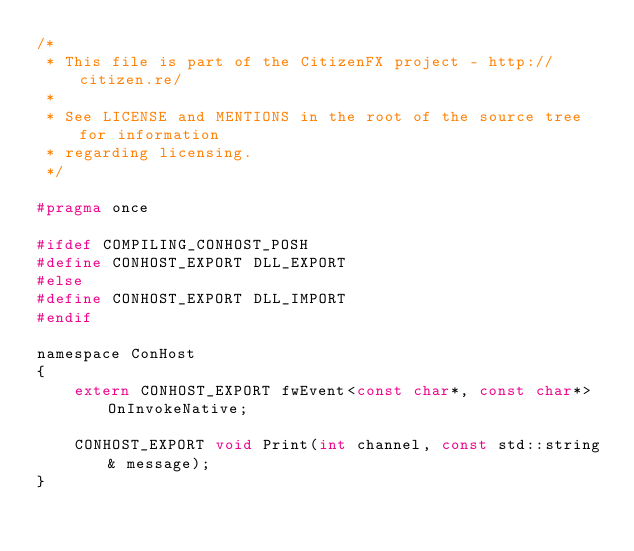<code> <loc_0><loc_0><loc_500><loc_500><_C_>/*
 * This file is part of the CitizenFX project - http://citizen.re/
 *
 * See LICENSE and MENTIONS in the root of the source tree for information
 * regarding licensing.
 */

#pragma once

#ifdef COMPILING_CONHOST_POSH
#define CONHOST_EXPORT DLL_EXPORT
#else
#define CONHOST_EXPORT DLL_IMPORT
#endif

namespace ConHost
{
	extern CONHOST_EXPORT fwEvent<const char*, const char*> OnInvokeNative;
	
	CONHOST_EXPORT void Print(int channel, const std::string& message);
}</code> 